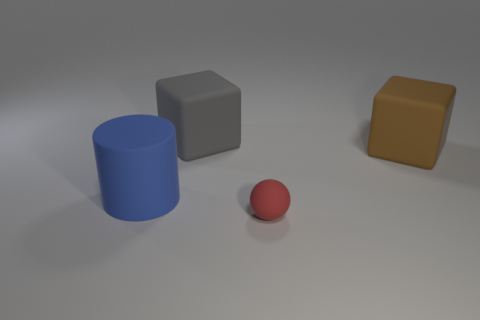What could be the significance of the different shapes in the image? The image may be a visual representation to distinguish between basic geometric shapes — a cylinder, cube, and sphere. These shapes could be used for educational purposes, like teaching geometry, demonstrating 3D rendering, or comparing how light and shadows fall on different surfaces. Could these shapes represent any concept in particular? While the shapes themselves could be purely illustrative, they might metaphorically represent various philosophical ideas such as equality and diversity — showing that like shapes, individuals can be distinct yet coexist harmoniously. They might also symbolize basic building blocks in various fields, from atoms in science to elements of design in art. 